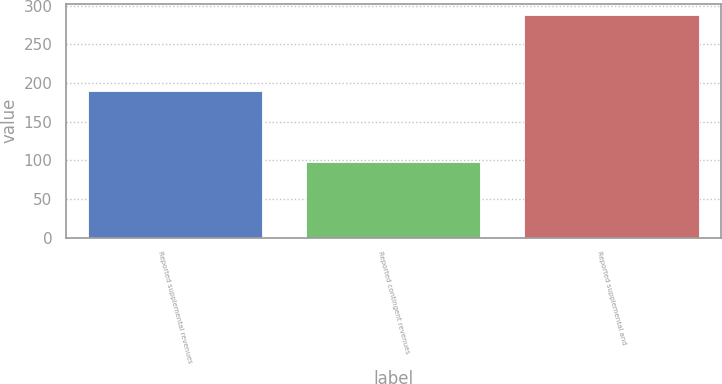Convert chart to OTSL. <chart><loc_0><loc_0><loc_500><loc_500><bar_chart><fcel>Reported supplemental revenues<fcel>Reported contingent revenues<fcel>Reported supplemental and<nl><fcel>189.9<fcel>98<fcel>287.9<nl></chart> 